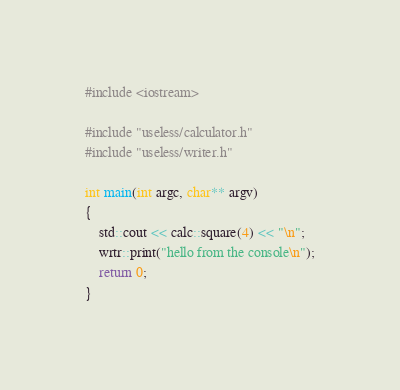Convert code to text. <code><loc_0><loc_0><loc_500><loc_500><_C++_>#include <iostream>

#include "useless/calculator.h"
#include "useless/writer.h"

int main(int argc, char** argv)
{
    std::cout << calc::square(4) << "\n";
    wrtr::print("hello from the console\n");
    return 0;
}</code> 